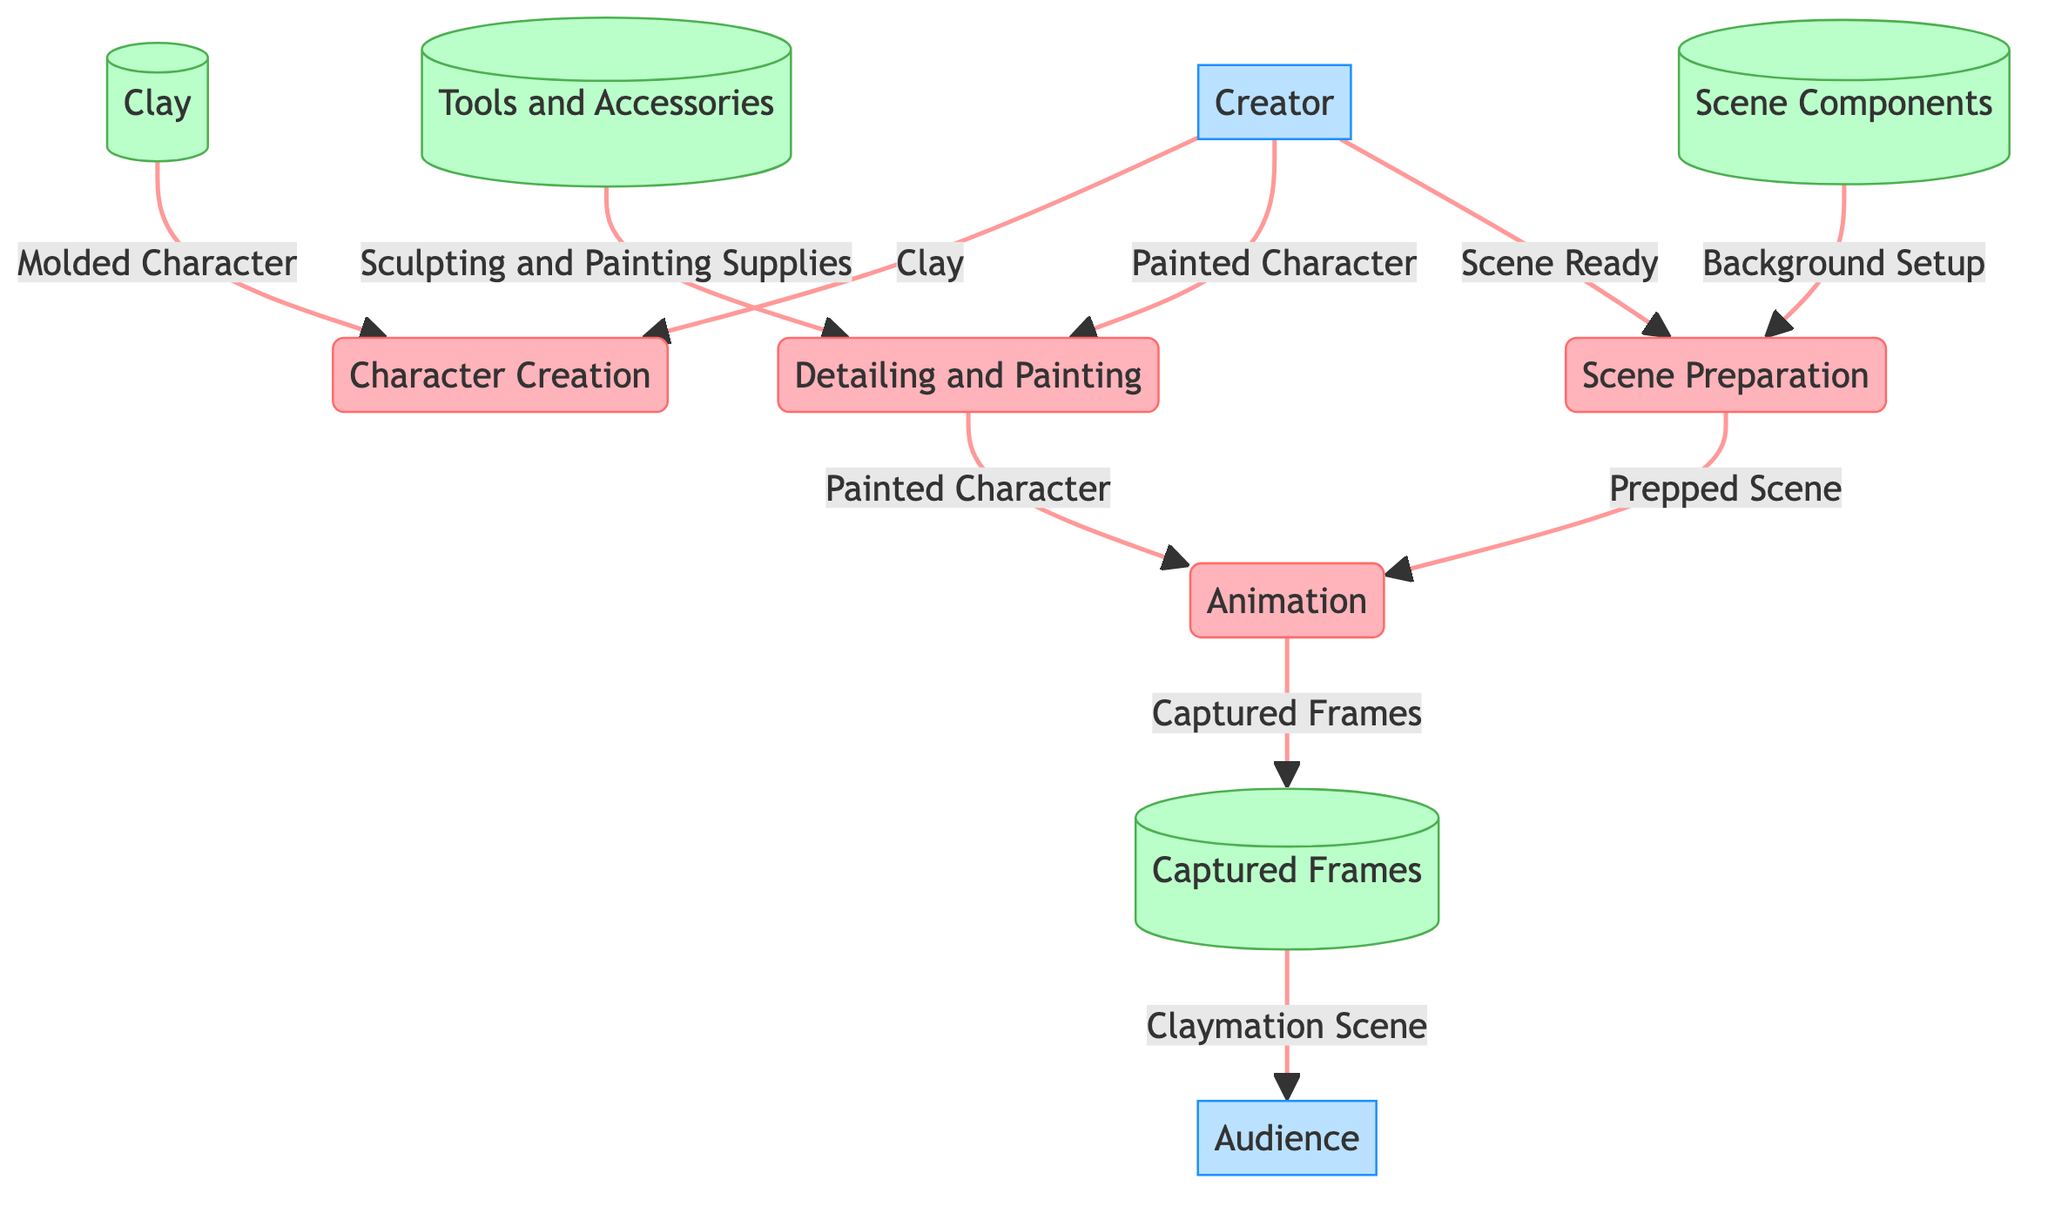What process comes after Character Creation? The diagram shows that after the process of Character Creation, the next process is Detailing and Painting. The flow of actions in the diagram directly indicates this order.
Answer: Detailing and Painting How many data stores are there in the diagram? The diagram lists four data stores: Clay, Tools and Accessories, Scene Components, and Captured Frames. By counting them, we find there are four data stores in total.
Answer: Four What data flows from the Creator to the Animation process? According to the diagram, the Creator sends the Painted Character to the Animation process. By tracing the arrow from Creator to Animation, we identify this flow.
Answer: Painted Character What is the last process before the audience receives the Claymation Scene? The last process shown in the diagram before the audience receives the Claymation Scene is Animation. This is where the frames are captured before they are sent to the Audience.
Answer: Animation Which data store is associated with Captured Frames? The Captured Frames are stored in the data store labeled D. In the diagram, D is visually linked to Captured Frames, indicating this association.
Answer: Captured Frames What is sent from the Scene Components to the Scene Preparation process? The diagram illustrates that the Scene Components send Background Setup to the Scene Preparation process. This flow is clearly drawn in the diagram.
Answer: Background Setup Who is responsible for creating the clay character? The diagram indicates that the Creator is responsible for the creation of the clay character. There is a direct connection labeled with the Creator's name, confirming this role.
Answer: Creator What is the initial material used in the Character Creation process? The diagram specifies that Clay is the initial material used in the Character Creation process. This is indicated directly by the flow from the Clay data store.
Answer: Clay 